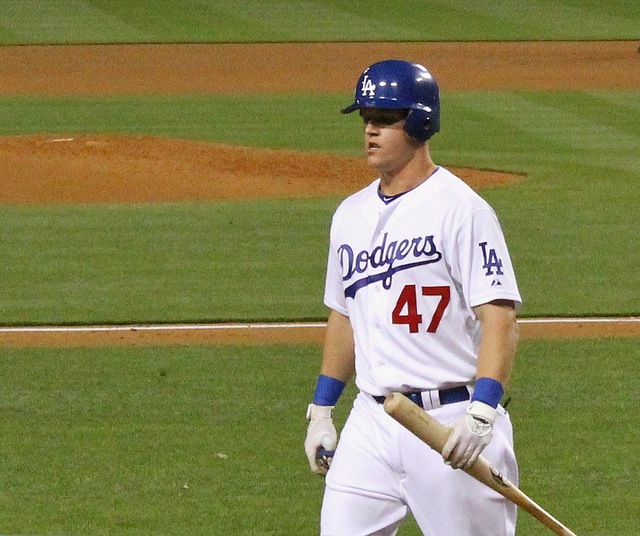Please transcribe the text information in this image. 47 Dodgers LA LA 